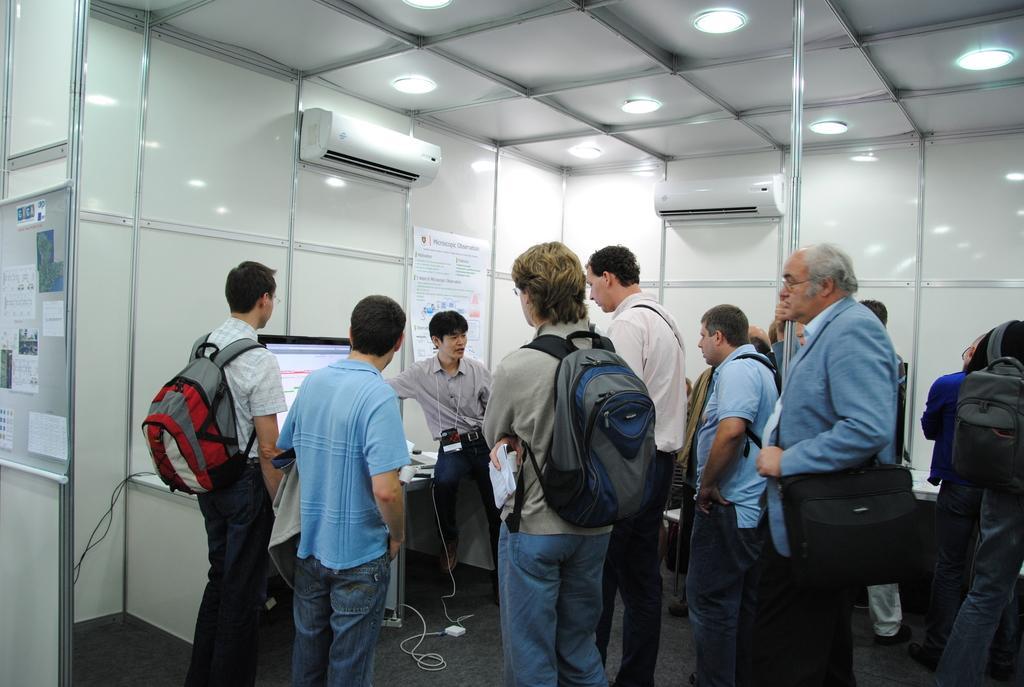Can you describe this image briefly? This image consists of many people. It looks like an office. At the bottom, there is a floor. On the left, we can see a monitor on the desk. And a person is sitting on the desk. In the background, there is a wall on which there are two air conditioners. At the top, there is a roof along with lights. On the left, there is a board on which there are papers. 